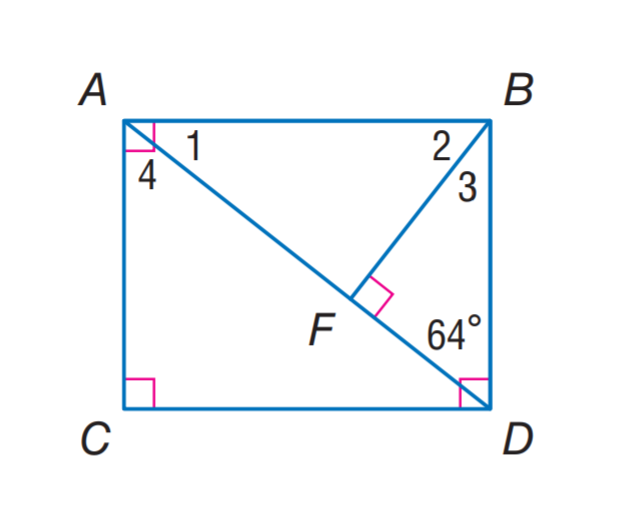Answer the mathemtical geometry problem and directly provide the correct option letter.
Question: Find m \angle 4.
Choices: A: 26 B: 32 C: 64 D: 78 C 